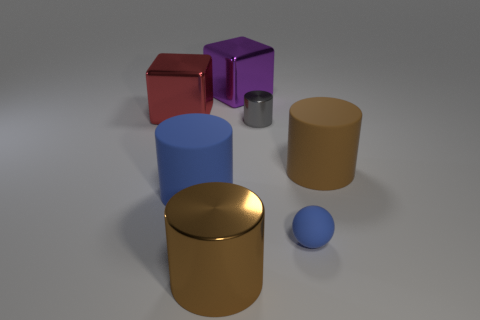Subtract all brown balls. How many brown cylinders are left? 2 Subtract all large cylinders. How many cylinders are left? 1 Add 1 tiny gray cylinders. How many objects exist? 8 Subtract all cyan cylinders. Subtract all cyan cubes. How many cylinders are left? 4 Subtract all purple shiny objects. Subtract all gray metallic cylinders. How many objects are left? 5 Add 4 big purple shiny things. How many big purple shiny things are left? 5 Add 4 small gray metal things. How many small gray metal things exist? 5 Subtract 0 brown blocks. How many objects are left? 7 Subtract all spheres. How many objects are left? 6 